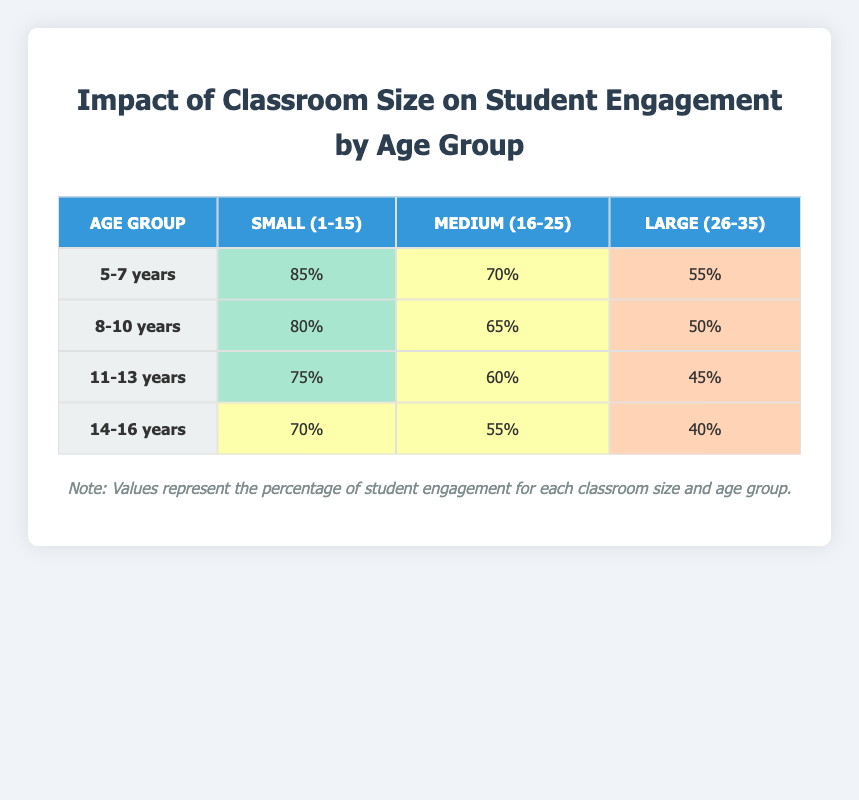What is the student engagement percentage for 11-13 years in a Small (1-15) classroom size? In the table, we look for the row labeled "11-13 years" and in the "Small (1-15)" column, it shows 75%.
Answer: 75% Which age group shows the highest student engagement percentage in a Medium (16-25) classroom size? In the Medium (16-25) column, we compare the engagement percentages: 70% (5-7 years), 65% (8-10 years), 60% (11-13 years), and 55% (14-16 years). The highest is 70% for the 5-7 years age group.
Answer: 5-7 years What is the difference in student engagement between the Large (26-35) and Small (1-15) classroom sizes for the 14-16 years age group? We find the engagement for 14-16 years: 40% for Large (26-35) and 70% for Small (1-15). The difference is calculated as 70% - 40% = 30%.
Answer: 30% Is it true that student engagement decreases as classroom size increases for the 8-10 years age group? We look at the engagement percentages for 8-10 years: 80% (Small), 65% (Medium), and 50% (Large). Since these values are decreasing as the classroom size increases, the statement is true.
Answer: Yes What is the average student engagement across all age groups for the Small (1-15) classroom size? We sum the percentages for the Small (1-15) classroom size: 85% + 80% + 75% + 70% = 310%. There are 4 age groups, so we divide the total by 4: 310% / 4 = 77.5%.
Answer: 77.5% 